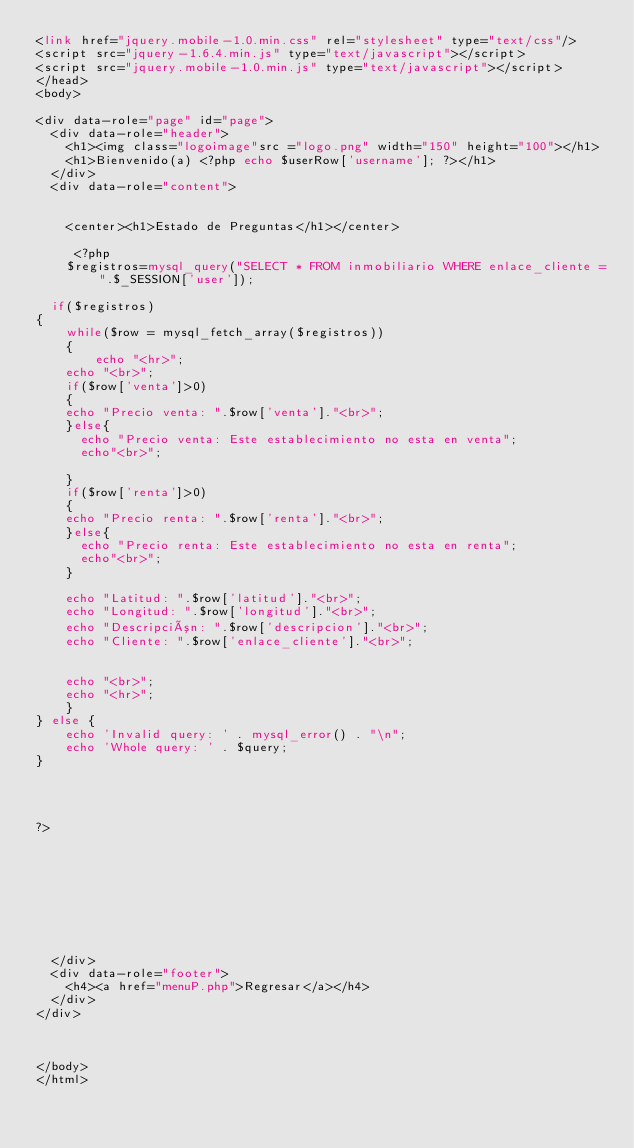<code> <loc_0><loc_0><loc_500><loc_500><_PHP_><link href="jquery.mobile-1.0.min.css" rel="stylesheet" type="text/css"/>
<script src="jquery-1.6.4.min.js" type="text/javascript"></script>
<script src="jquery.mobile-1.0.min.js" type="text/javascript"></script>
</head> 
<body> 

<div data-role="page" id="page">
	<div data-role="header">
		<h1><img class="logoimage"src ="logo.png" width="150" height="100"></h1>
		<h1>Bienvenido(a) <?php echo $userRow['username']; ?></h1>
	</div>
	<div data-role="content">	
		

		<center><h1>Estado de Preguntas</h1></center>   
     
     <?php
	 	$registros=mysql_query("SELECT * FROM inmobiliario WHERE enlace_cliente =".$_SESSION['user']);
		
	if($registros)
{
    while($row = mysql_fetch_array($registros))
    {
        echo "<hr>";
		echo "<br>";
		if($row['venta']>0)
		{
		echo "Precio venta: ".$row['venta']."<br>";
		}else{
			echo "Precio venta: Este establecimiento no esta en venta";
			echo"<br>";

		}
		if($row['renta']>0)
		{
		echo "Precio renta: ".$row['renta']."<br>";
		}else{
			echo "Precio renta: Este establecimiento no esta en renta";
			echo"<br>";
		}
		
		echo "Latitud: ".$row['latitud']."<br>";
		echo "Longitud: ".$row['longitud']."<br>";
		echo "Descripción: ".$row['descripcion']."<br>";
		echo "Cliente: ".$row['enlace_cliente']."<br>";
		
		
		echo "<br>";
		echo "<hr>";
    }
} else {
    echo 'Invalid query: ' . mysql_error() . "\n";
    echo 'Whole query: ' . $query; 
}
	

	

?>
	

	






	</div>
	<div data-role="footer">
		<h4><a href="menuP.php">Regresar</a></h4>
	</div>
</div>



</body>
</html></code> 